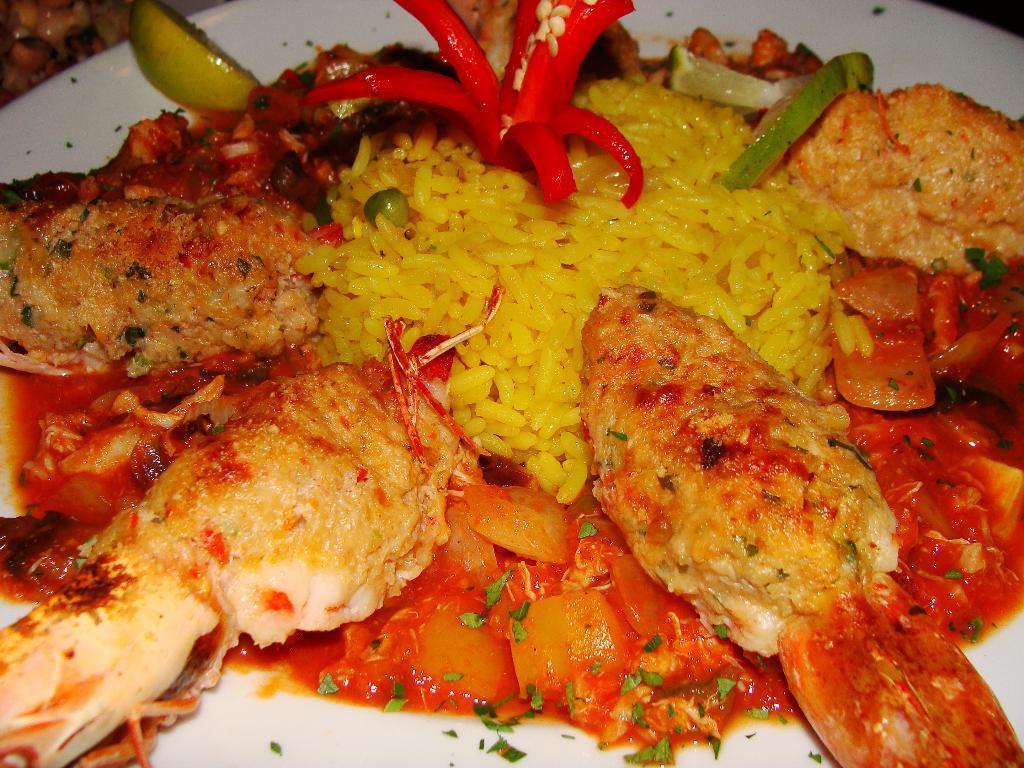Describe this image in one or two sentences. In this image, we can see some food items are placed on the white plate. 